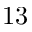Convert formula to latex. <formula><loc_0><loc_0><loc_500><loc_500>1 3</formula> 